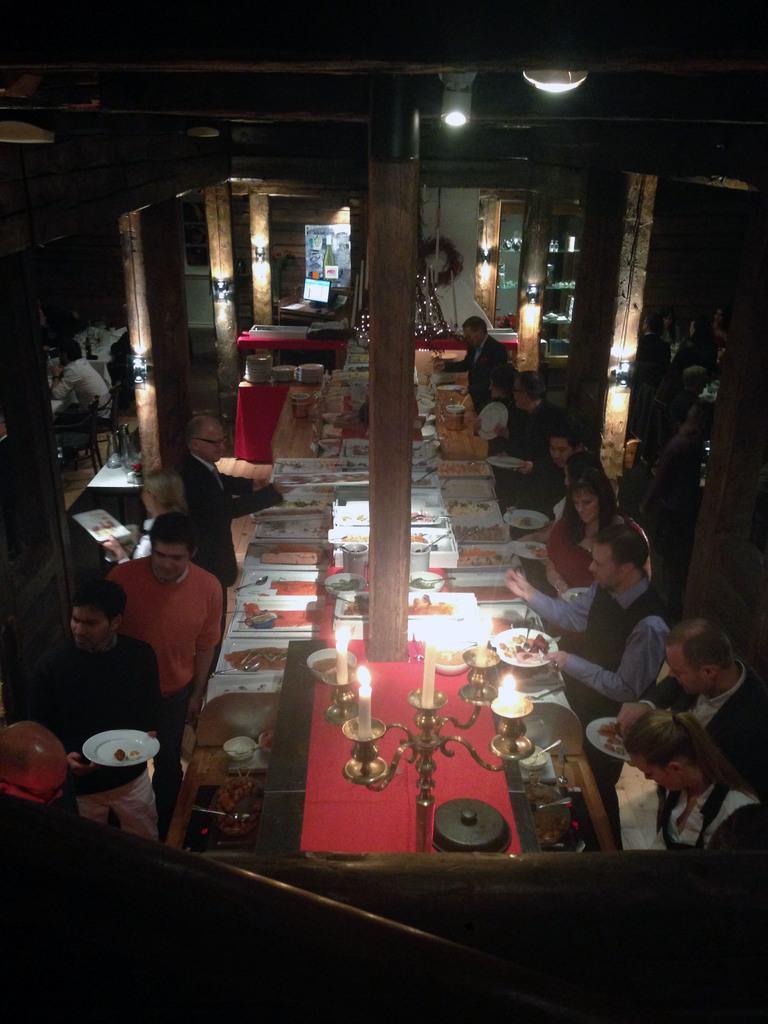Describe this image in one or two sentences. In this image I can see few people sitting on chairs around the table, on the table I can see few plates, few candles, few bowls and few spoons, To the left side of the image I can see few people standing on the other side of the table. in the background I can see few people sitting on chairs ,few pillars,few light and the ceiling. 